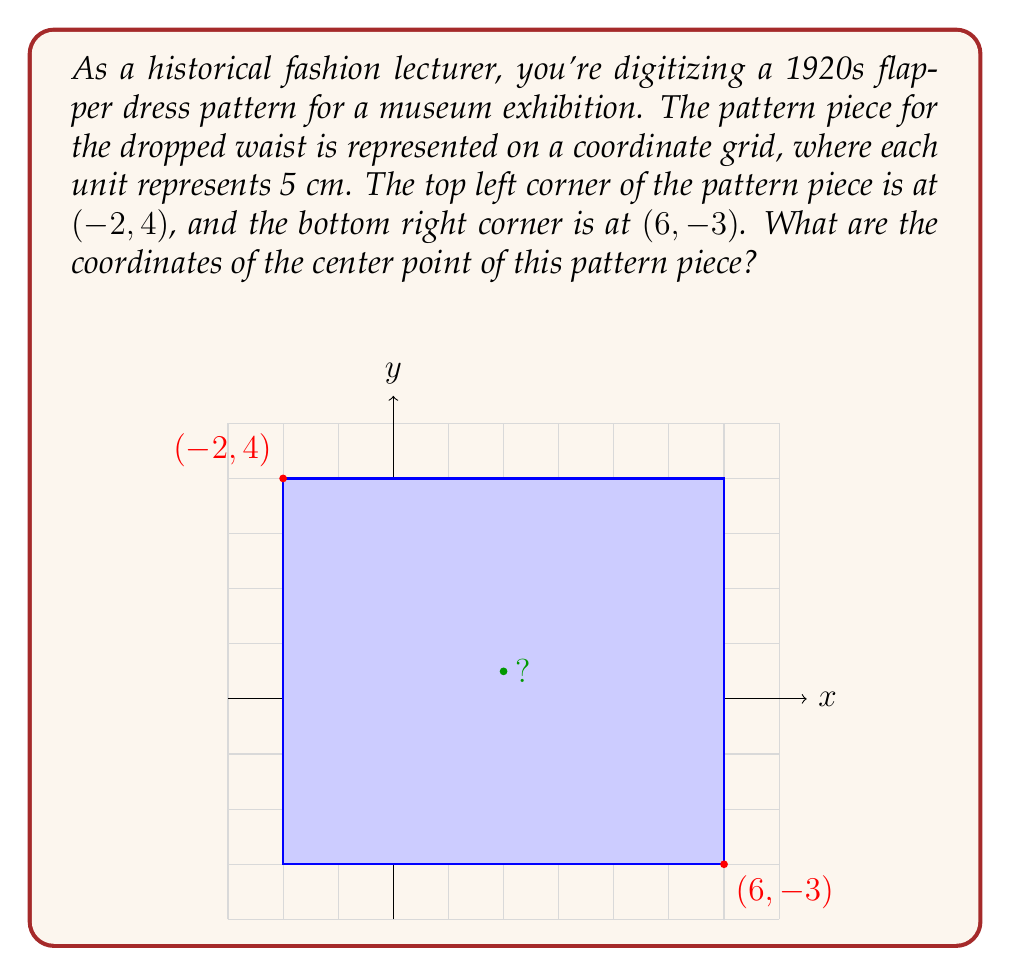Solve this math problem. To find the coordinates of the center point of the pattern piece, we need to follow these steps:

1) First, let's identify the x-coordinates of the left and right sides:
   Left side: $x = -2$
   Right side: $x = 6$

2) The x-coordinate of the center will be halfway between these two points:
   $$x_{center} = \frac{-2 + 6}{2} = \frac{4}{2} = 2$$

3) Now, let's identify the y-coordinates of the top and bottom sides:
   Top side: $y = 4$
   Bottom side: $y = -3$

4) The y-coordinate of the center will be halfway between these two points:
   $$y_{center} = \frac{4 + (-3)}{2} = \frac{1}{2} = 0.5$$

5) Therefore, the center point coordinates are (2, 0.5).

Note: In the context of the 1920s flapper dress, this center point could represent a key feature of the dropped waist design, crucial for maintaining the characteristic loose, straight silhouette of the era.
Answer: (2, 0.5) 